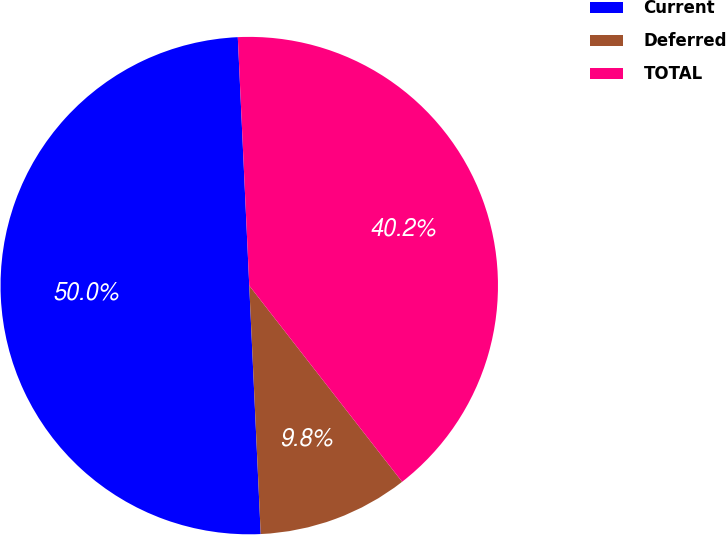Convert chart. <chart><loc_0><loc_0><loc_500><loc_500><pie_chart><fcel>Current<fcel>Deferred<fcel>TOTAL<nl><fcel>50.0%<fcel>9.8%<fcel>40.2%<nl></chart> 